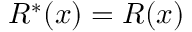Convert formula to latex. <formula><loc_0><loc_0><loc_500><loc_500>R ^ { * } ( x ) = R ( x )</formula> 